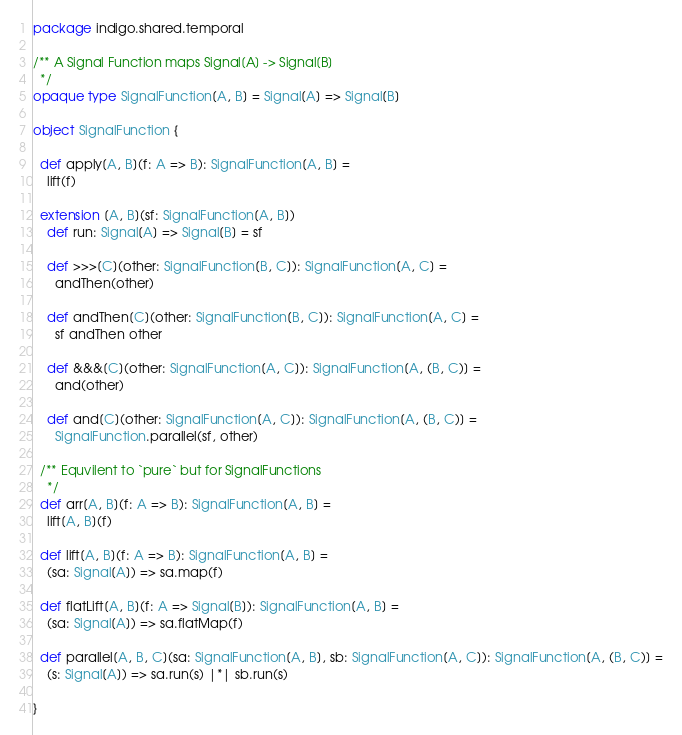Convert code to text. <code><loc_0><loc_0><loc_500><loc_500><_Scala_>package indigo.shared.temporal

/** A Signal Function maps Signal[A] -> Signal[B]
  */
opaque type SignalFunction[A, B] = Signal[A] => Signal[B]

object SignalFunction {

  def apply[A, B](f: A => B): SignalFunction[A, B] =
    lift(f)

  extension [A, B](sf: SignalFunction[A, B])
    def run: Signal[A] => Signal[B] = sf

    def >>>[C](other: SignalFunction[B, C]): SignalFunction[A, C] =
      andThen(other)

    def andThen[C](other: SignalFunction[B, C]): SignalFunction[A, C] =
      sf andThen other

    def &&&[C](other: SignalFunction[A, C]): SignalFunction[A, (B, C)] =
      and(other)

    def and[C](other: SignalFunction[A, C]): SignalFunction[A, (B, C)] =
      SignalFunction.parallel(sf, other)

  /** Equvilent to `pure` but for SignalFunctions
    */
  def arr[A, B](f: A => B): SignalFunction[A, B] =
    lift[A, B](f)

  def lift[A, B](f: A => B): SignalFunction[A, B] =
    (sa: Signal[A]) => sa.map(f)

  def flatLift[A, B](f: A => Signal[B]): SignalFunction[A, B] =
    (sa: Signal[A]) => sa.flatMap(f)

  def parallel[A, B, C](sa: SignalFunction[A, B], sb: SignalFunction[A, C]): SignalFunction[A, (B, C)] =
    (s: Signal[A]) => sa.run(s) |*| sb.run(s)

}
</code> 